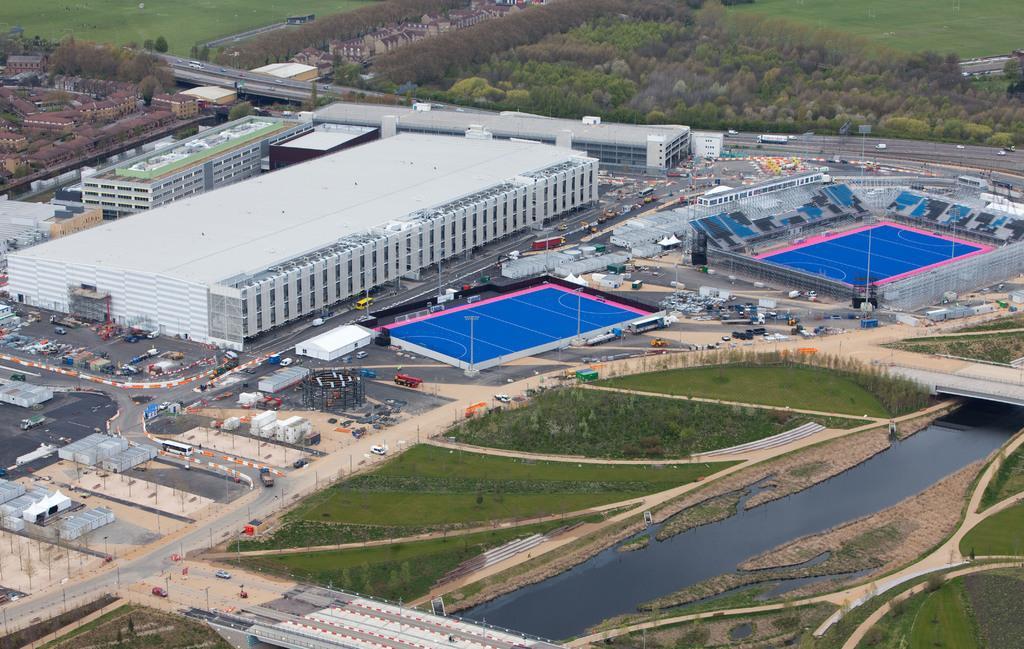Could you give a brief overview of what you see in this image? This is an outside view. On the right side there is a lake, a bridge and grass on the ground and also there are many trees. On the left side there are many buildings and vehicles on the roads and also I can see two stadiums. At the top of the image there are many trees. 